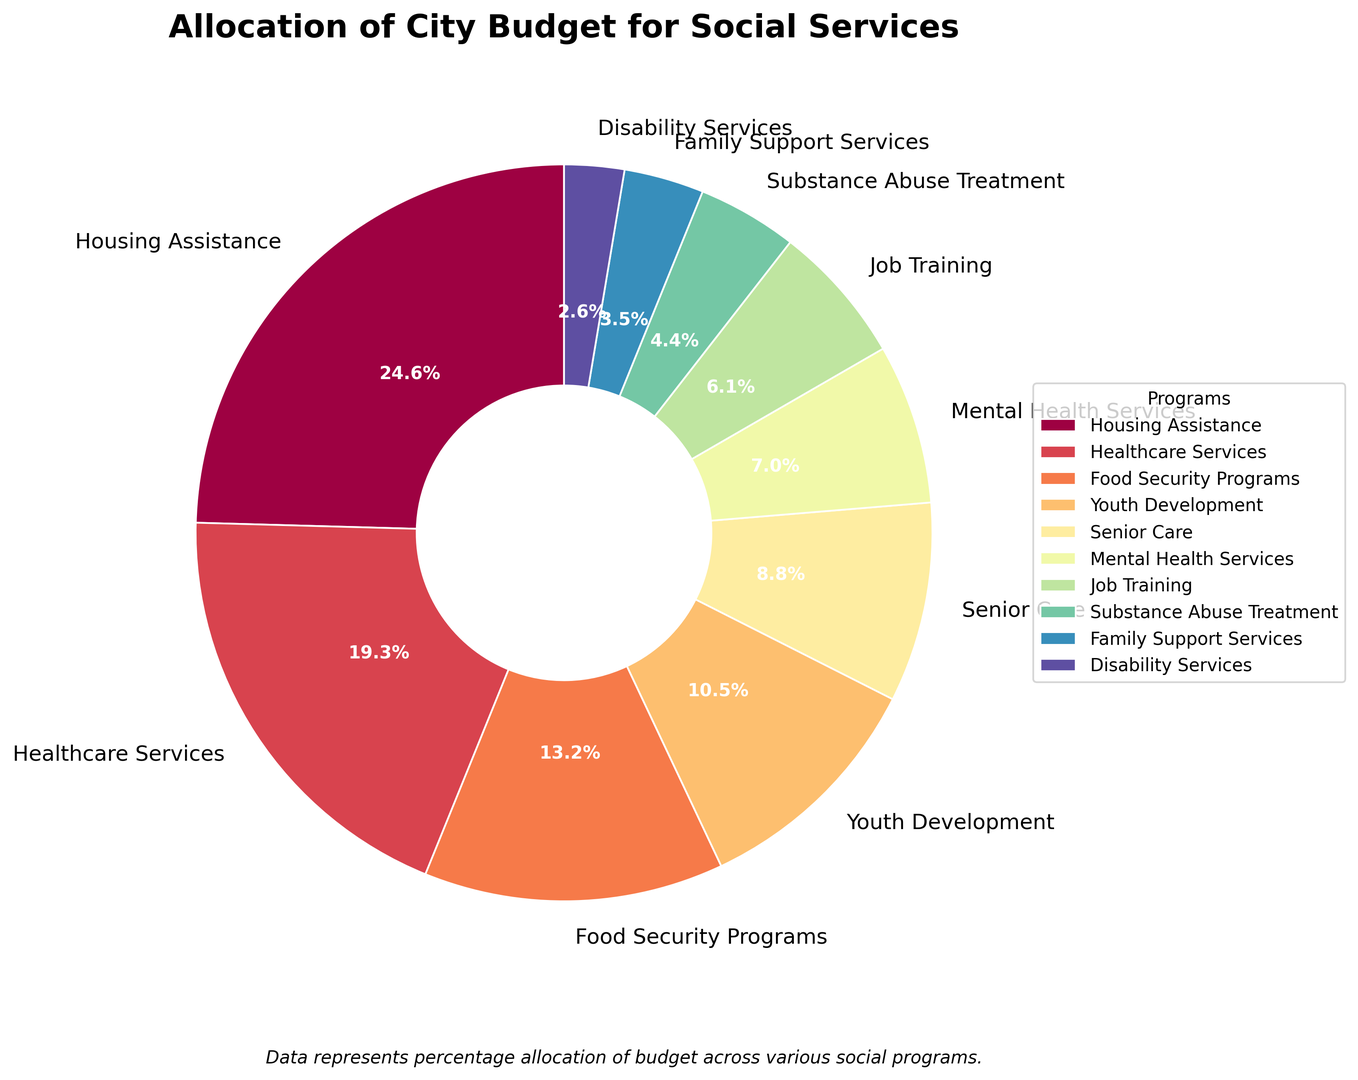Which program receives the largest allocation of the budget? By observing the pie chart, the program marked with the largest slice corresponds to Housing Assistance.
Answer: Housing Assistance Which two programs combined receive an allocation closest to 20%? Adding the smaller portions, Job Training (7%) and Mental Health Services (8%), and Substance Abuse Treatment (5%) results in 20%.
Answer: Job Training and Mental Health Services What is the difference in budget allocation between Healthcare Services and Youth Development? Healthcare Services is allocated 22%, and Youth Development is allocated 12%, so the difference is 22% - 12% = 10%.
Answer: 10% Is the budget allocation for Senior Care more than twice that of Disability Services? Senior Care is allocated 10%, and Disability Services is allocated 3%. Double of Disability Services is 3% * 2 = 6%, which is less than Senior Care's allocation.
Answer: Yes Which program has a lighter shade of color, Mental Health Services or Substance Abuse Treatment? Upon visual inspection, the Mental Health Services wedge appears to be in a lighter shade compared to Substance Abuse Treatment's wedge.
Answer: Mental Health Services How much more is allocated to Housing Assistance compared to Food Security Programs? Housing Assistance has 28%, and Food Security Programs have 15%. The difference is 28% - 15% = 13%.
Answer: 13% Which programs receive an allocation of less than 10%? Observing the chart, the programs with less than 10% are Mental Health Services (8%), Job Training (7%), Substance Abuse Treatment (5%), Family Support Services (4%), Disability Services (3%).
Answer: Mental Health Services, Job Training, Substance Abuse Treatment, Family Support Services, Disability Services If the total budget is $1,000,000, what is the dollar allocation for Senior Care? Senior Care is allocated 10% of the total budget. So, the allocation is 10% of $1,000,000, which is $1,000,000 * 0.10 = $100,000.
Answer: $100,000 Which two categories have the most similar budget allocations? By comparing the budget percentages, Youth Development (12%) and Senior Care (10%) have the most similar allocations with only a 2% difference.
Answer: Youth Development and Senior Care 